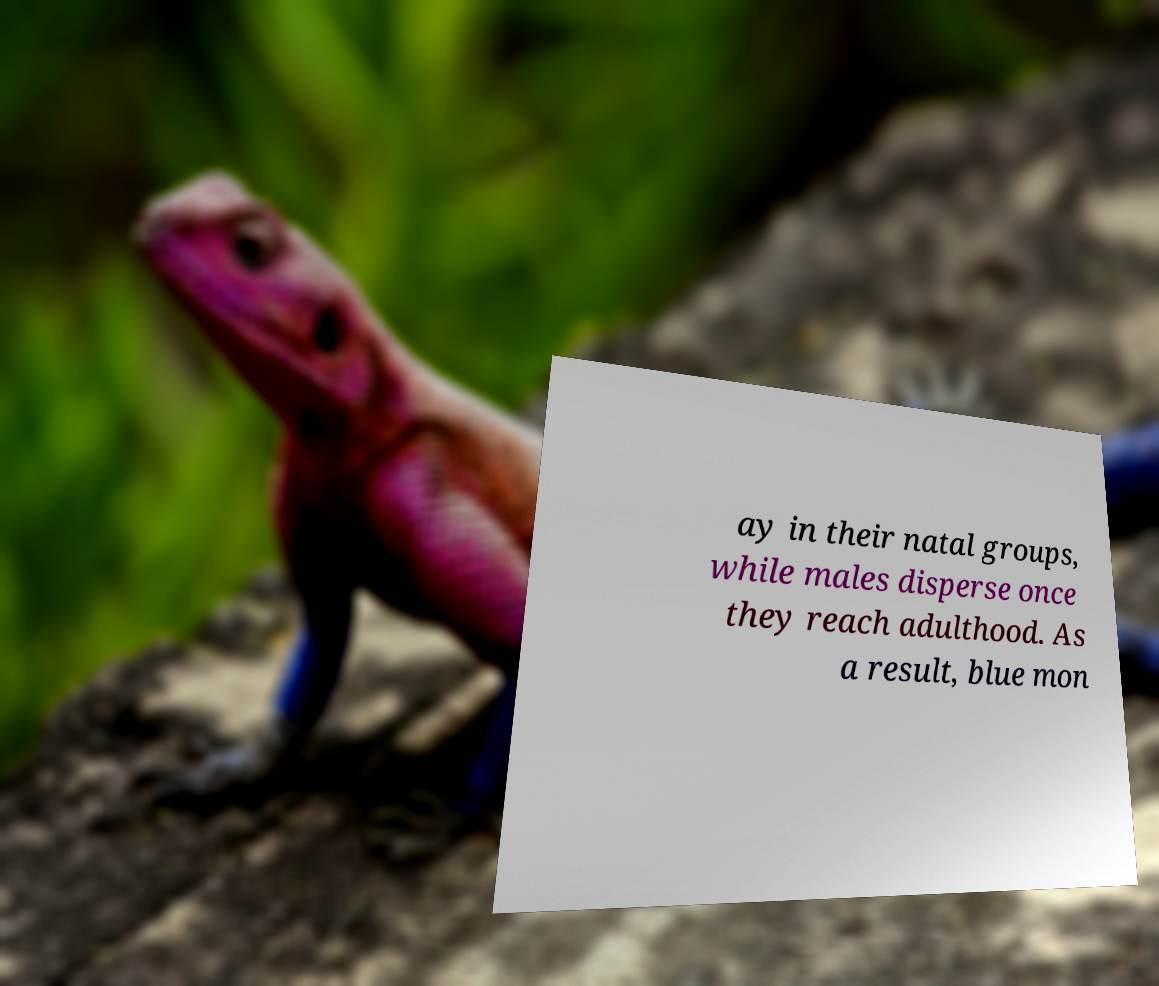What messages or text are displayed in this image? I need them in a readable, typed format. ay in their natal groups, while males disperse once they reach adulthood. As a result, blue mon 